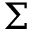Convert formula to latex. <formula><loc_0><loc_0><loc_500><loc_500>\Sigma</formula> 